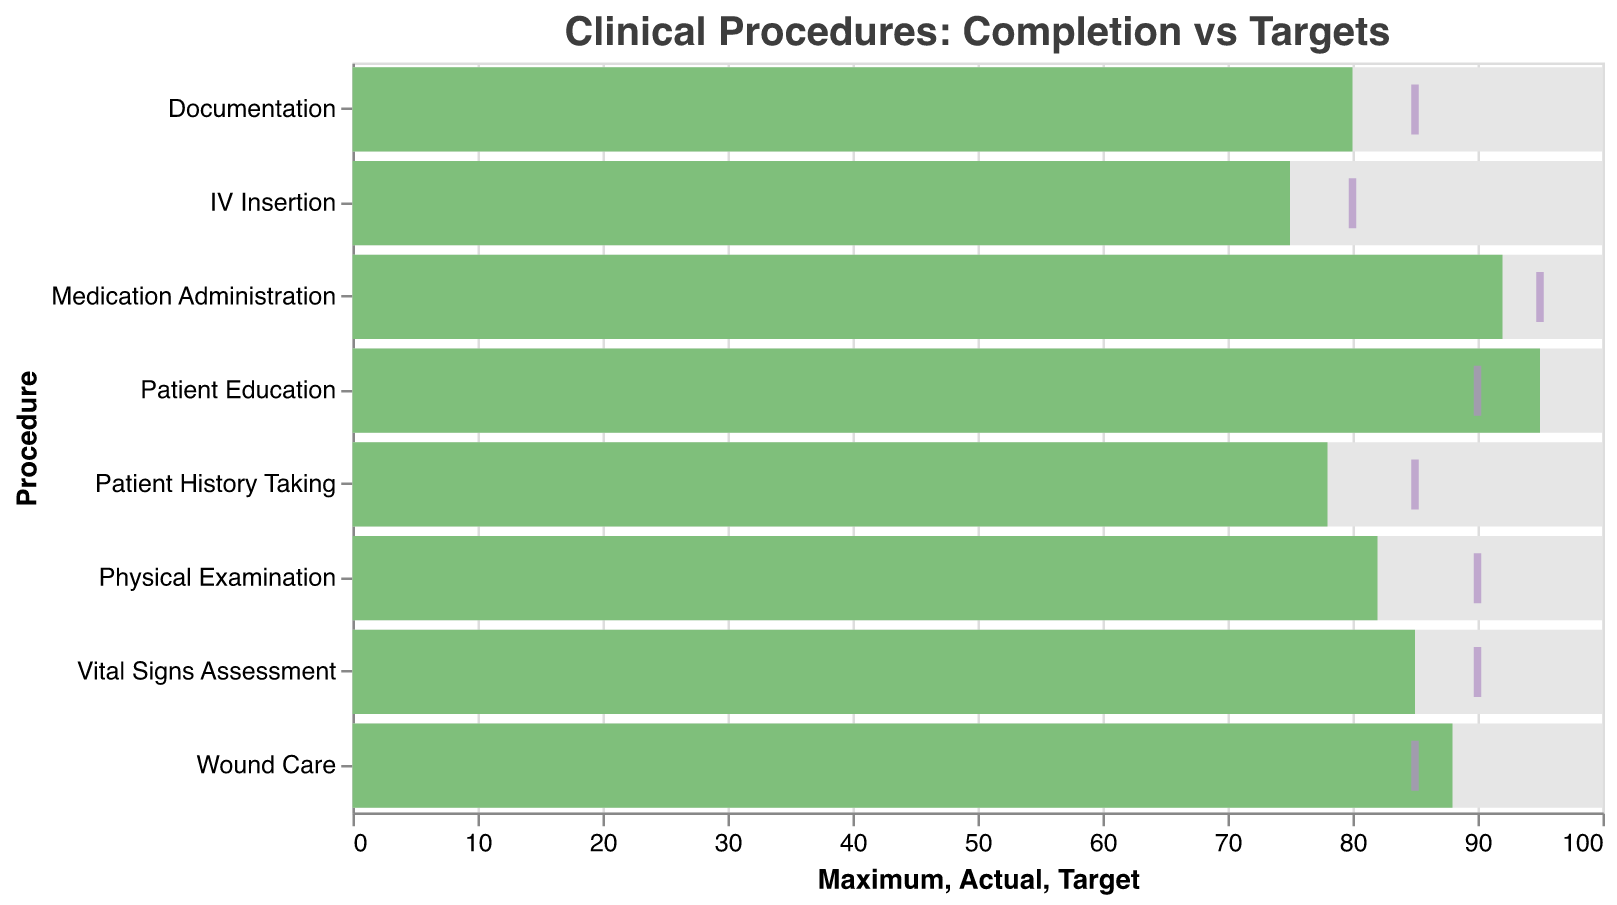What's the title of the figure? The title is usually located at the top of the figure and is clearly displayed as "Clinical Procedures: Completion vs Targets".
Answer: Clinical Procedures: Completion vs Targets How many different procedures are represented in the figure? Each bar represents a procedure; counting the bars yields the total number of different procedures.
Answer: 8 Which procedure has the highest actual completion rate? Look for the longest green bar which represents the actual completion rate; "Patient Education" has the longest green bar at 95.
Answer: Patient Education What is the target value for Vital Signs Assessment? Locate the tick mark for "Vital Signs Assessment" on the chart, which represents the target value.
Answer: 90 How many procedures have actual completion rates higher than their targets? Compare the length of the green bar (Actual) to the position of the purple tick mark (Target) for each procedure to find which are greater.
Answer: 3 What is the difference between the target and actual value for IV Insertion? Subtract the actual value (75) from the target value (80) for IV Insertion.
Answer: 5 Which procedure shows the largest gap between the target and actual completion rates? Calculate the difference between the target and actual for each procedure and identify the largest gap.
Answer: Patient History Taking What is the average actual completion rate for all procedures? Add all the actual completion rates (85, 78, 82, 92, 88, 75, 95, 80) and divide by the number of procedures (8).
Answer: 84.38 How does the actual completion rate of Documentation compare with its target? Compare the green bar (Actual = 80) with the purple tick mark (Target = 85) for Documentation; the actual value is less.
Answer: Less than What's the overall range of the target values in the chart? Identify the minimum (80 for IV Insertion) and maximum (95 for Medication Administration) target values and find the range by subtracting the minimum from the maximum.
Answer: 15 